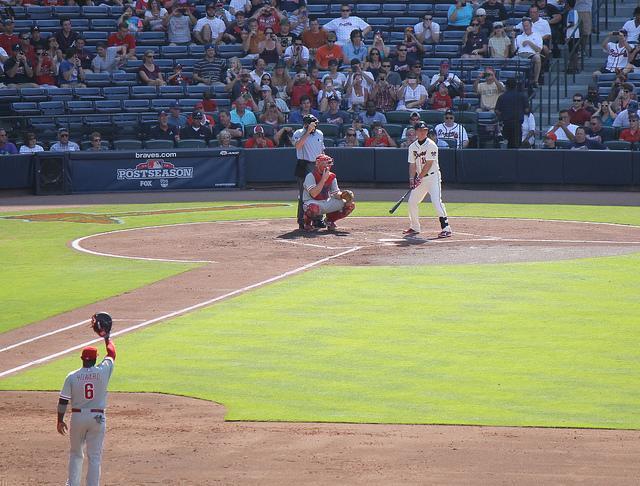What switch hitting Atlanta Braves legend is at the plate?
Choose the right answer and clarify with the format: 'Answer: answer
Rationale: rationale.'
Options: Ozzie albies, chipper jones, freddie freeman, otis nixon. Answer: chipper jones.
Rationale: Based on his physical characteristics, that batter is none other than atlanta braves switch hitter chipper jones. 